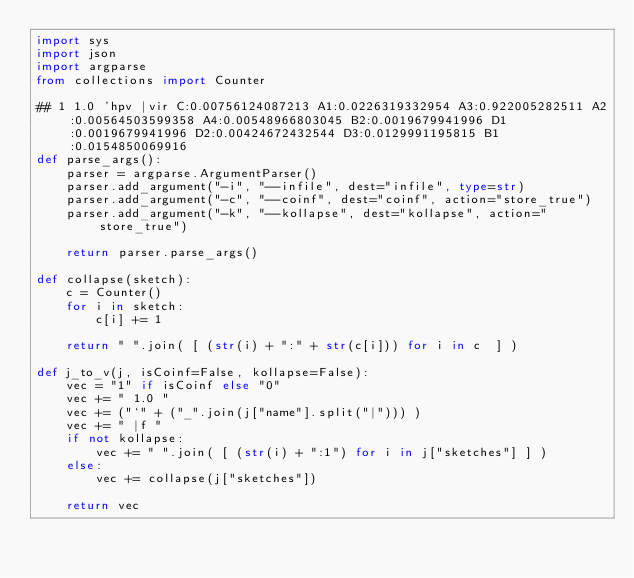<code> <loc_0><loc_0><loc_500><loc_500><_Python_>import sys
import json
import argparse
from collections import Counter

## 1 1.0 'hpv |vir C:0.00756124087213 A1:0.0226319332954 A3:0.922005282511 A2:0.00564503599358 A4:0.00548966803045 B2:0.0019679941996 D1:0.0019679941996 D2:0.00424672432544 D3:0.0129991195815 B1:0.0154850069916
def parse_args():
    parser = argparse.ArgumentParser()
    parser.add_argument("-i", "--infile", dest="infile", type=str)
    parser.add_argument("-c", "--coinf", dest="coinf", action="store_true")
    parser.add_argument("-k", "--kollapse", dest="kollapse", action="store_true")

    return parser.parse_args()

def collapse(sketch):
    c = Counter()
    for i in sketch:
        c[i] += 1
    
    return " ".join( [ (str(i) + ":" + str(c[i])) for i in c  ] )

def j_to_v(j, isCoinf=False, kollapse=False):
    vec = "1" if isCoinf else "0"
    vec += " 1.0 "
    vec += ("`" + ("_".join(j["name"].split("|"))) )
    vec += " |f "
    if not kollapse:
        vec += " ".join( [ (str(i) + ":1") for i in j["sketches"] ] )
    else:
        vec += collapse(j["sketches"])

    return vec

</code> 